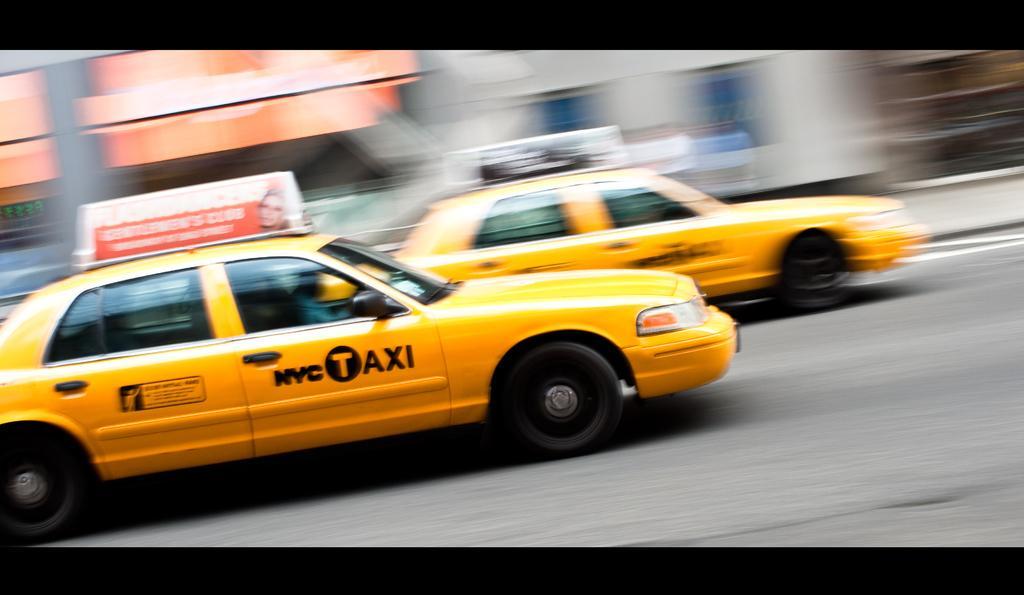Could you give a brief overview of what you see in this image? This picture seems to be an edited image with the black borders. In the center we can see the two yellow cars running on the road. In the background we can see the buildings and we can see text on the cars. 